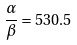<formula> <loc_0><loc_0><loc_500><loc_500>\frac { \alpha } { \beta } = 5 3 0 . 5</formula> 